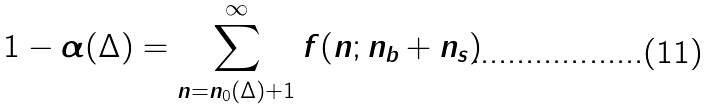Convert formula to latex. <formula><loc_0><loc_0><loc_500><loc_500>1 - \alpha ( \Delta ) = \sum ^ { \infty } _ { n = n _ { 0 } ( \Delta ) + 1 } f ( n ; n _ { b } + n _ { s } )</formula> 